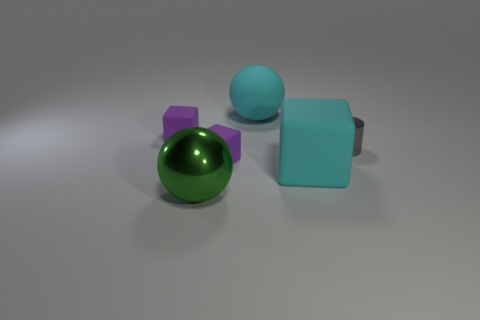Subtract all tiny cubes. How many cubes are left? 1 Subtract all green balls. How many purple blocks are left? 2 Subtract all green blocks. Subtract all cyan cylinders. How many blocks are left? 3 Add 3 large rubber blocks. How many objects exist? 9 Subtract all cylinders. How many objects are left? 5 Add 5 matte cubes. How many matte cubes exist? 8 Subtract 0 yellow spheres. How many objects are left? 6 Subtract all small brown spheres. Subtract all large rubber cubes. How many objects are left? 5 Add 3 tiny cylinders. How many tiny cylinders are left? 4 